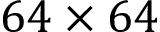<formula> <loc_0><loc_0><loc_500><loc_500>6 4 \times 6 4</formula> 